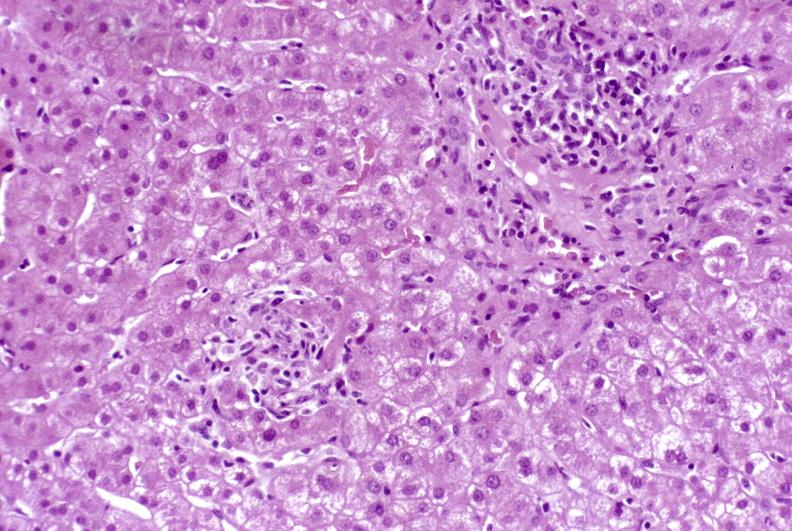s hepatobiliary present?
Answer the question using a single word or phrase. Yes 